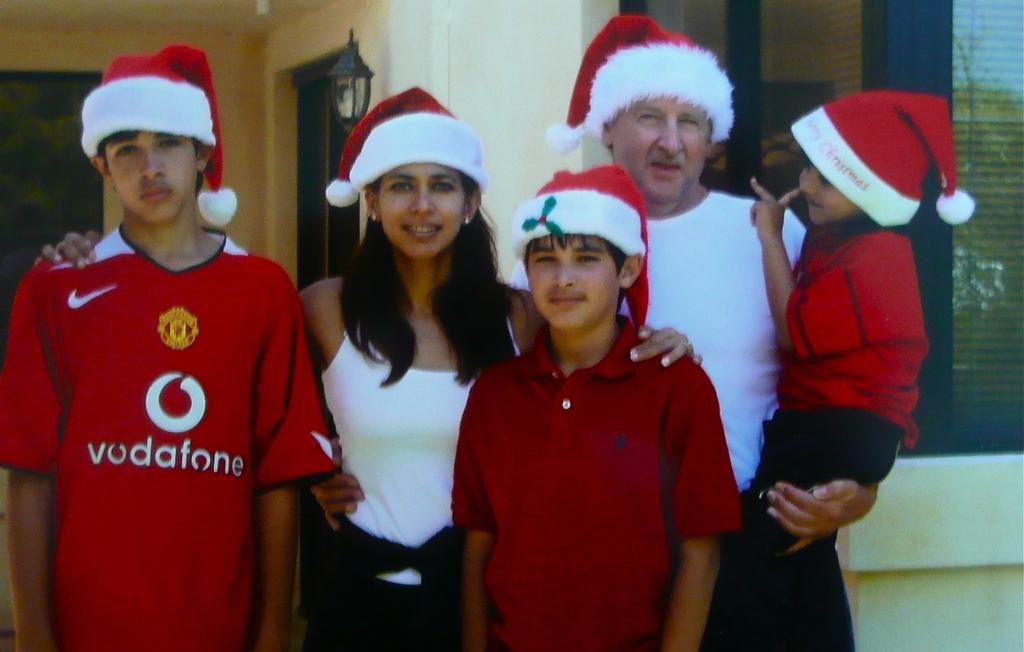What team jersey is the boy wearing?
Your answer should be compact. Vodafone. 